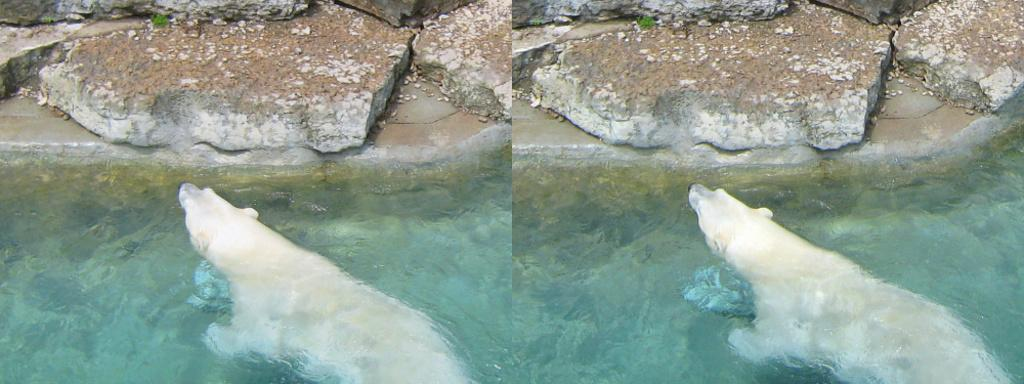What animal can be seen in the water in the image? There is a bear in the water in the image. What type of objects are present at the top side of the image? There are stones at the top side of the image. What type of toy can be seen in the bear's paw in the image? There is no toy present in the image, and the bear's paws are not visible in the water. 